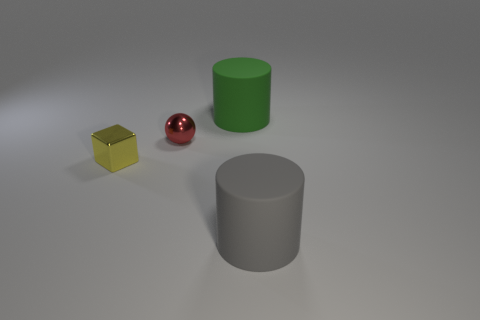What number of things are either rubber cylinders on the left side of the large gray cylinder or large matte objects that are on the left side of the gray rubber cylinder?
Give a very brief answer. 1. There is a gray thing; does it have the same size as the object that is to the left of the red ball?
Offer a terse response. No. Does the big object behind the small metal ball have the same material as the thing left of the red shiny object?
Give a very brief answer. No. Are there an equal number of tiny shiny objects to the right of the tiny red metallic object and gray cylinders that are behind the large green object?
Provide a succinct answer. Yes. How many matte cylinders are the same color as the ball?
Offer a terse response. 0. How many metal things are either large cyan blocks or cylinders?
Your answer should be compact. 0. There is a large thing in front of the small ball; does it have the same shape as the large matte thing behind the gray rubber object?
Your answer should be compact. Yes. There is a metallic sphere; how many large green objects are behind it?
Make the answer very short. 1. Are there any tiny spheres made of the same material as the small yellow block?
Give a very brief answer. Yes. What is the material of the yellow thing that is the same size as the red metallic thing?
Offer a terse response. Metal. 